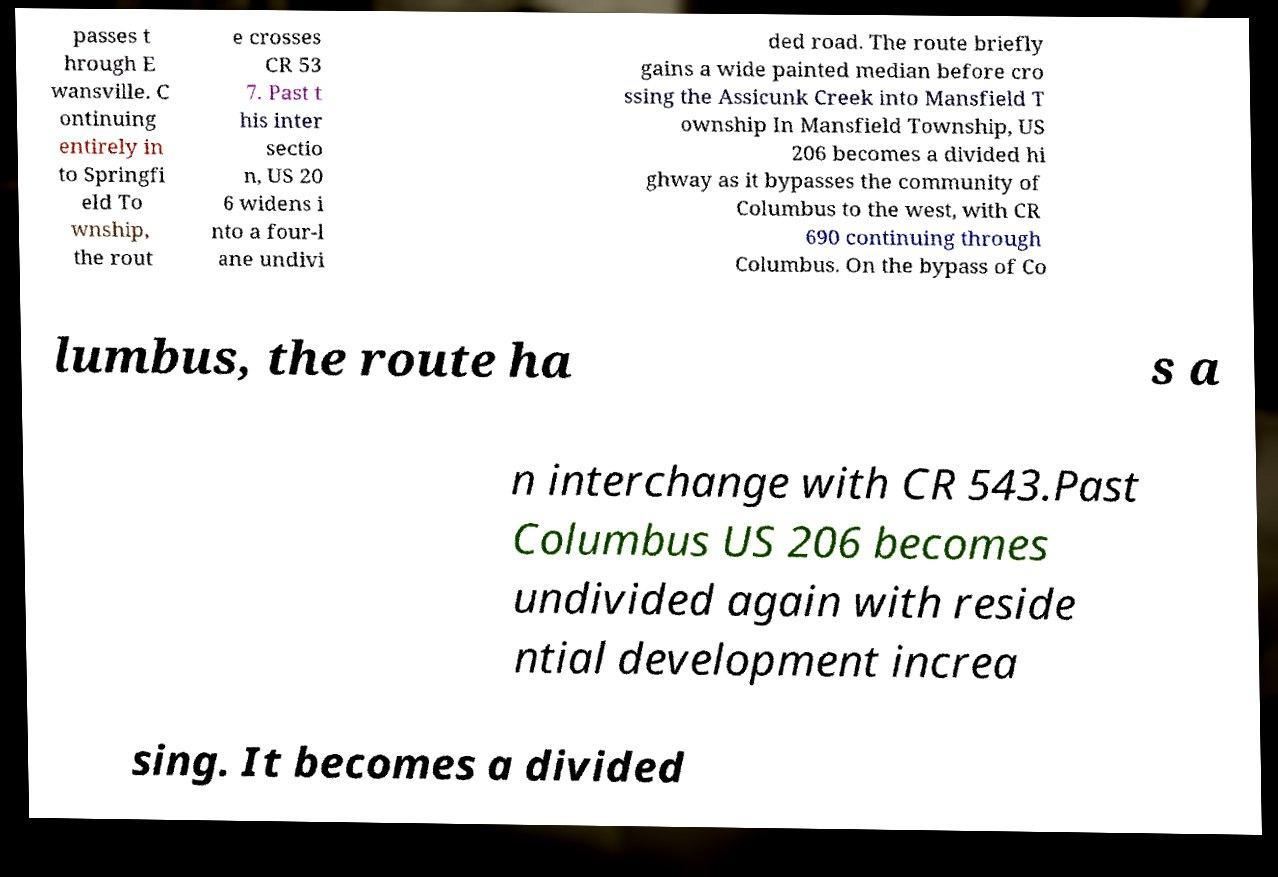Could you assist in decoding the text presented in this image and type it out clearly? passes t hrough E wansville. C ontinuing entirely in to Springfi eld To wnship, the rout e crosses CR 53 7. Past t his inter sectio n, US 20 6 widens i nto a four-l ane undivi ded road. The route briefly gains a wide painted median before cro ssing the Assicunk Creek into Mansfield T ownship In Mansfield Township, US 206 becomes a divided hi ghway as it bypasses the community of Columbus to the west, with CR 690 continuing through Columbus. On the bypass of Co lumbus, the route ha s a n interchange with CR 543.Past Columbus US 206 becomes undivided again with reside ntial development increa sing. It becomes a divided 